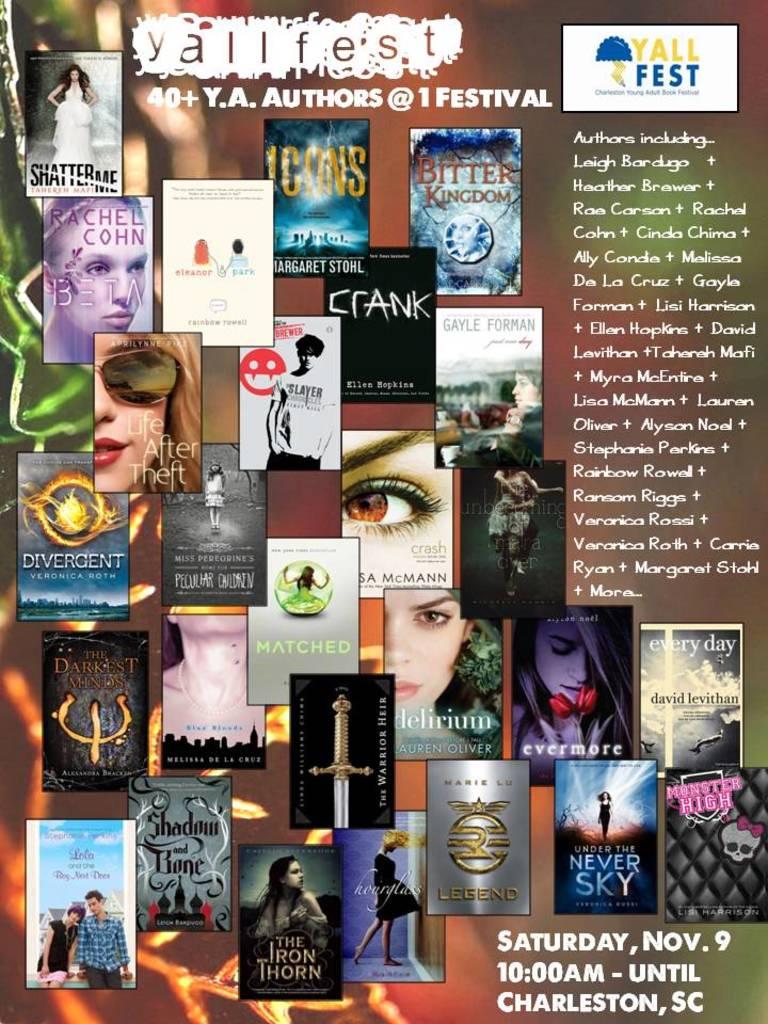What day is this festival?
Ensure brevity in your answer.  Saturday nov 9. In what city and state does this festival take place?
Provide a short and direct response. Charleston, sc. 